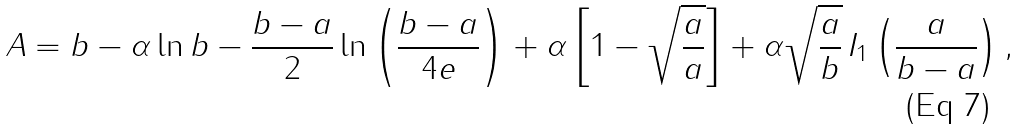Convert formula to latex. <formula><loc_0><loc_0><loc_500><loc_500>A = b - \alpha \ln b - \frac { b - a } { 2 } \ln \left ( \frac { b - a } { 4 e } \right ) + \alpha \left [ 1 - { \sqrt { \frac { a } { a } } } \right ] + \alpha { \sqrt { \frac { a } { b } } } \, I _ { 1 } \left ( \frac { a } { b - a } \right ) ,</formula> 